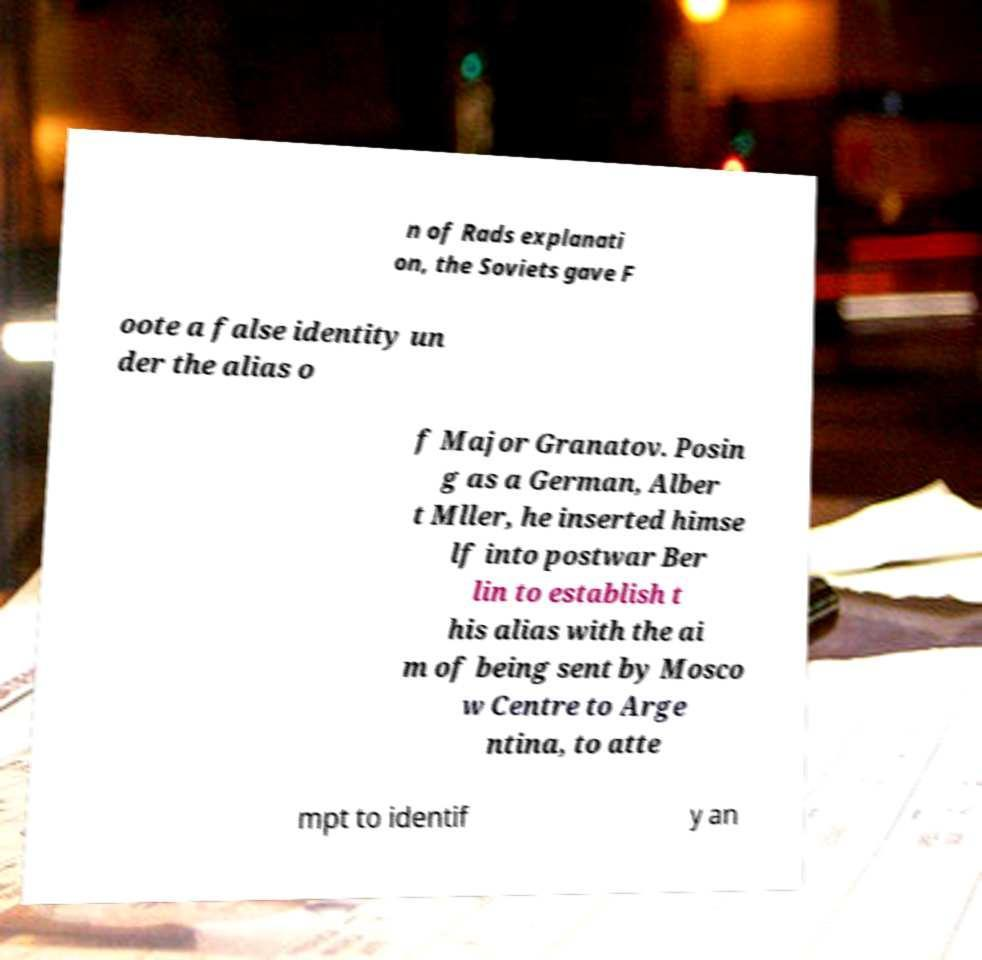I need the written content from this picture converted into text. Can you do that? n of Rads explanati on, the Soviets gave F oote a false identity un der the alias o f Major Granatov. Posin g as a German, Alber t Mller, he inserted himse lf into postwar Ber lin to establish t his alias with the ai m of being sent by Mosco w Centre to Arge ntina, to atte mpt to identif y an 